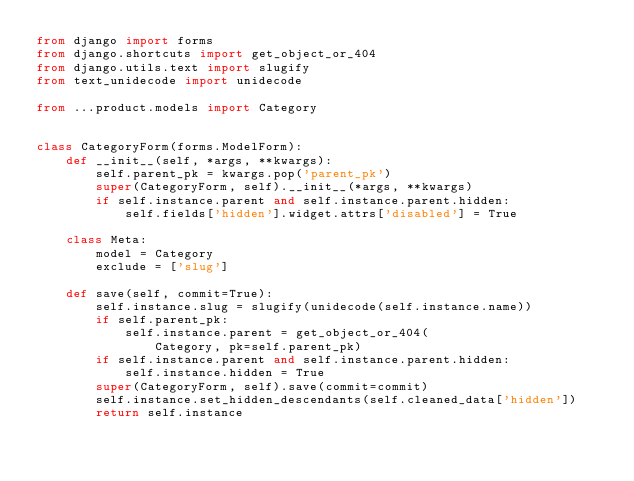Convert code to text. <code><loc_0><loc_0><loc_500><loc_500><_Python_>from django import forms
from django.shortcuts import get_object_or_404
from django.utils.text import slugify
from text_unidecode import unidecode

from ...product.models import Category


class CategoryForm(forms.ModelForm):
    def __init__(self, *args, **kwargs):
        self.parent_pk = kwargs.pop('parent_pk')
        super(CategoryForm, self).__init__(*args, **kwargs)
        if self.instance.parent and self.instance.parent.hidden:
            self.fields['hidden'].widget.attrs['disabled'] = True

    class Meta:
        model = Category
        exclude = ['slug']

    def save(self, commit=True):
        self.instance.slug = slugify(unidecode(self.instance.name))
        if self.parent_pk:
            self.instance.parent = get_object_or_404(
                Category, pk=self.parent_pk)
        if self.instance.parent and self.instance.parent.hidden:
            self.instance.hidden = True
        super(CategoryForm, self).save(commit=commit)
        self.instance.set_hidden_descendants(self.cleaned_data['hidden'])
        return self.instance
</code> 